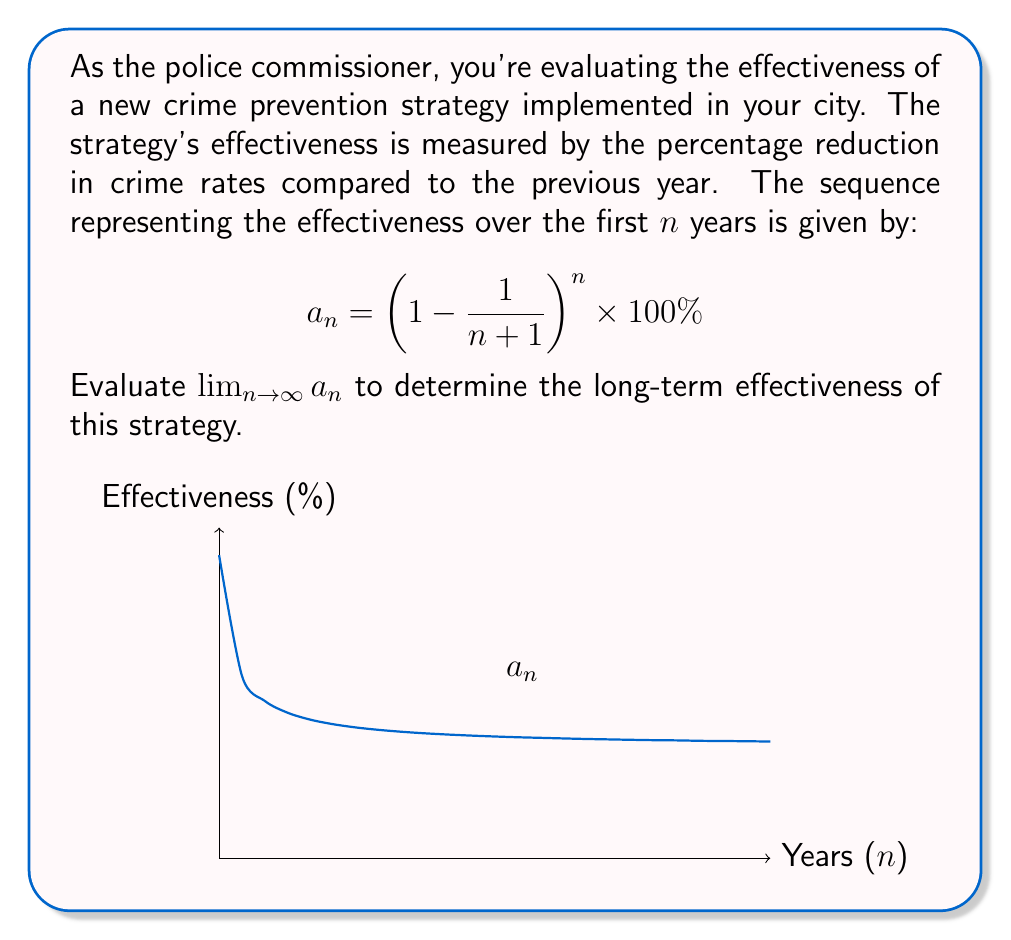Can you answer this question? To evaluate this limit, we'll follow these steps:

1) First, recognize that this limit is related to the famous limit that defines Euler's number e:

   $\lim_{n \to \infty} \left(1 + \frac{1}{n}\right)^n = e$

2) We can rewrite our sequence in a similar form:

   $a_n = \left(1 - \frac{1}{n+1}\right)^n \times 100\%$
   $= \left[\left(1 - \frac{1}{n+1}\right)^{n+1}\right]^{\frac{n}{n+1}} \times 100\%$

3) Now, let's focus on the inner part:

   $\lim_{n \to \infty} \left(1 - \frac{1}{n+1}\right)^{n+1} = \frac{1}{e}$

   This is because $\left(1 - \frac{1}{n+1}\right)^{n+1}$ is the reciprocal of $\left(1 + \frac{1}{n}\right)^n$ as $n$ approaches infinity.

4) For the exponent:

   $\lim_{n \to \infty} \frac{n}{n+1} = 1$

5) Putting it all together:

   $\lim_{n \to \infty} a_n = \lim_{n \to \infty} \left[\left(1 - \frac{1}{n+1}\right)^{n+1}\right]^{\frac{n}{n+1}} \times 100\%$
   $= \left(\frac{1}{e}\right)^1 \times 100\%$
   $= \frac{100\%}{e}$

6) Evaluating this numerically:

   $\frac{100\%}{e} \approx 36.79\%$

Therefore, the long-term effectiveness of the crime prevention strategy approaches approximately 36.79%.
Answer: $\frac{100}{e}\%$ or approximately $36.79\%$ 